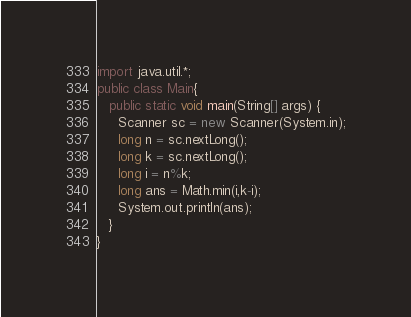<code> <loc_0><loc_0><loc_500><loc_500><_Java_>import java.util.*;
public class Main{
   public static void main(String[] args) {
     Scanner sc = new Scanner(System.in);
     long n = sc.nextLong();
     long k = sc.nextLong();
     long i = n%k;
     long ans = Math.min(i,k-i);
     System.out.println(ans);
   }
}
</code> 